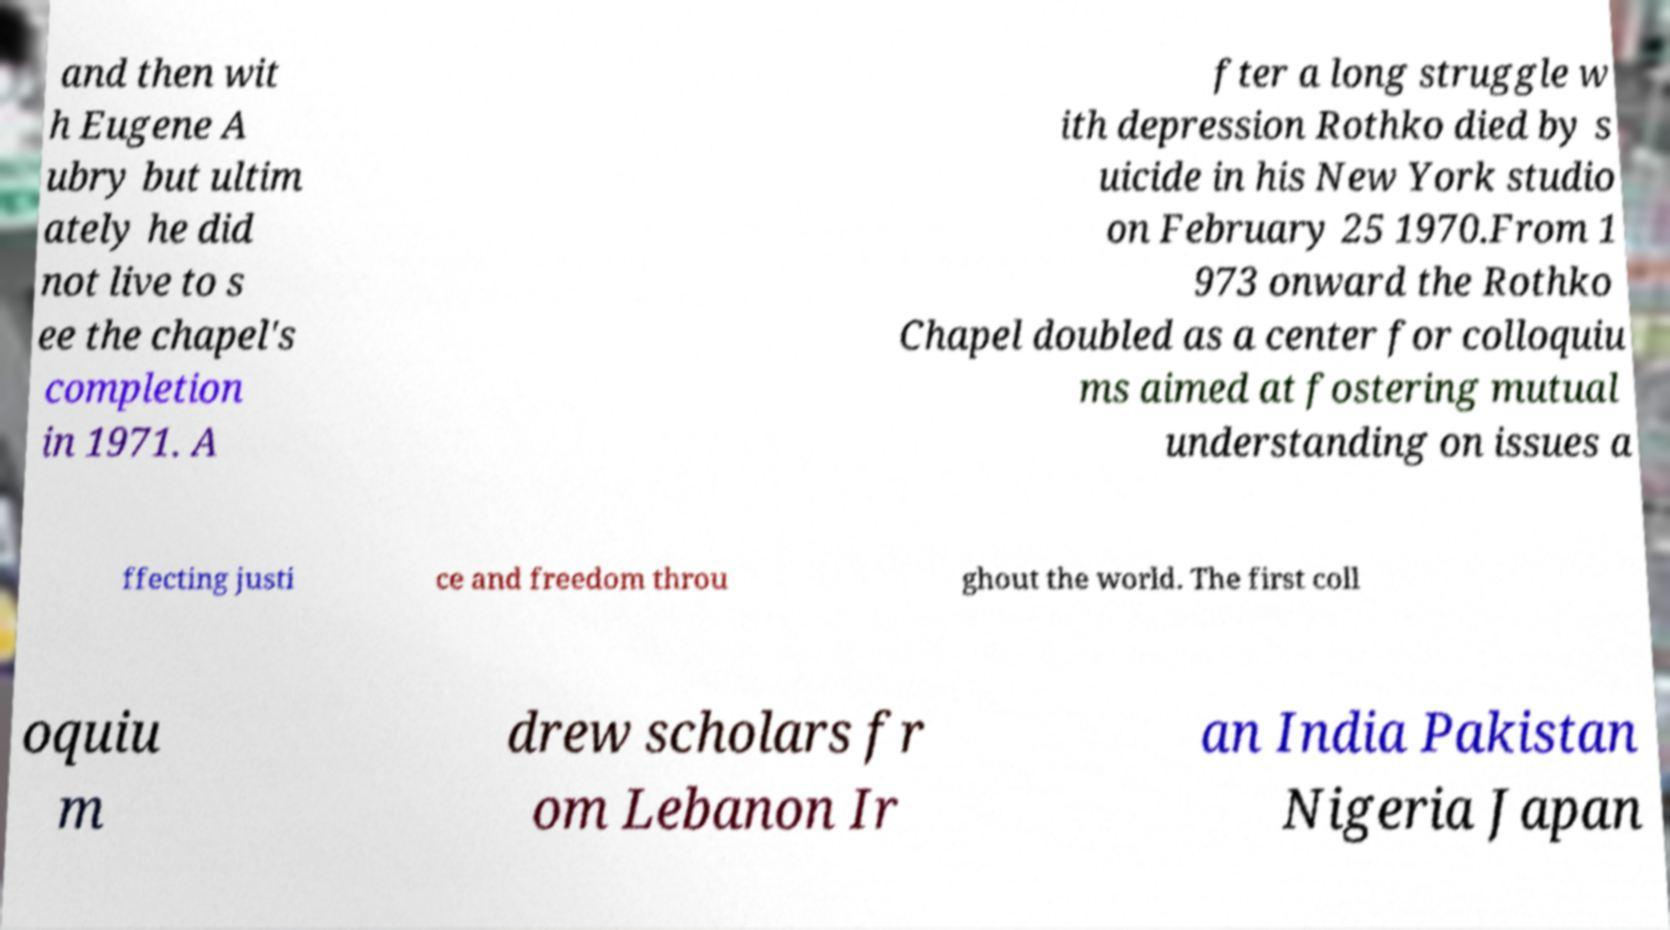For documentation purposes, I need the text within this image transcribed. Could you provide that? and then wit h Eugene A ubry but ultim ately he did not live to s ee the chapel's completion in 1971. A fter a long struggle w ith depression Rothko died by s uicide in his New York studio on February 25 1970.From 1 973 onward the Rothko Chapel doubled as a center for colloquiu ms aimed at fostering mutual understanding on issues a ffecting justi ce and freedom throu ghout the world. The first coll oquiu m drew scholars fr om Lebanon Ir an India Pakistan Nigeria Japan 